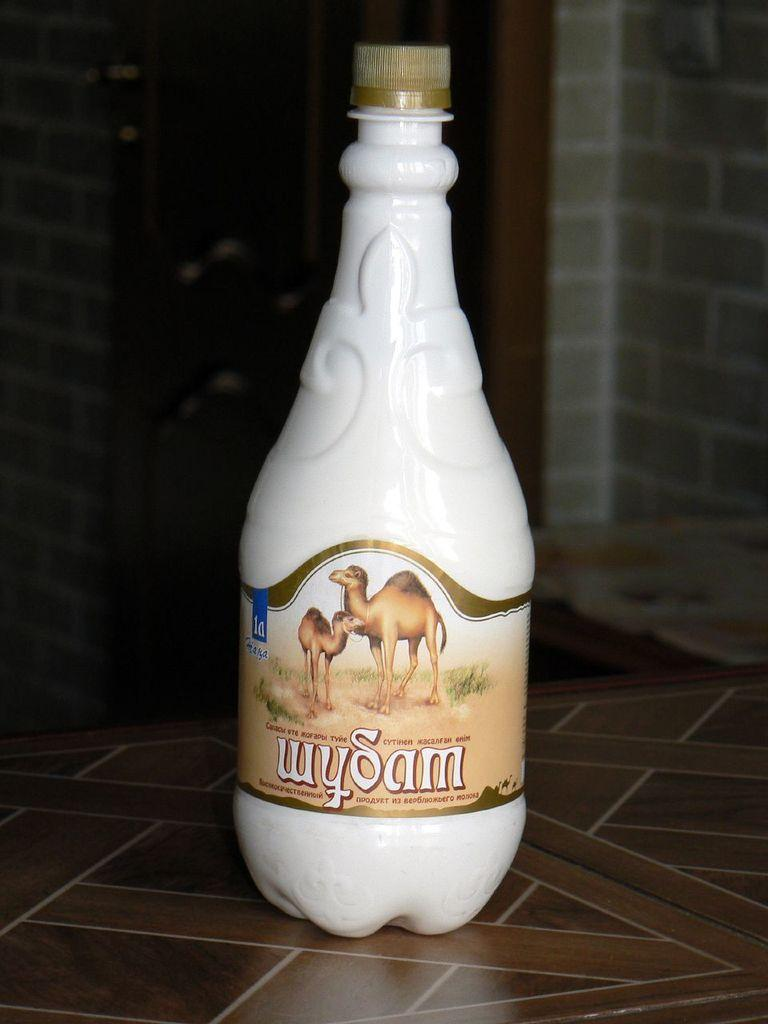<image>
Give a short and clear explanation of the subsequent image. A bottle of wySam shows two camels on the label. 